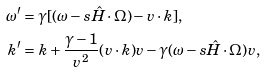Convert formula to latex. <formula><loc_0><loc_0><loc_500><loc_500>\omega ^ { \prime } & = \gamma [ ( \omega - s \hat { H } \cdot \Omega ) - v \cdot k ] , \\ k ^ { \prime } & = k + \frac { \gamma - 1 } { v ^ { 2 } } ( v \cdot k ) v - \gamma ( \omega - s \hat { H } \cdot \Omega ) v ,</formula> 